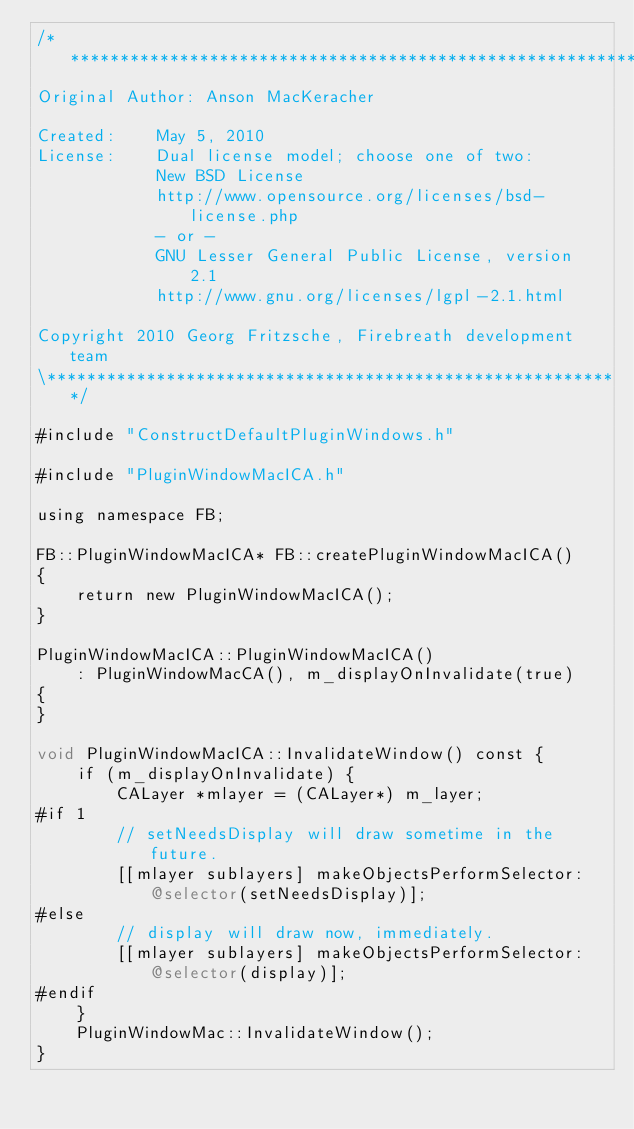Convert code to text. <code><loc_0><loc_0><loc_500><loc_500><_ObjectiveC_>/**********************************************************\
Original Author: Anson MacKeracher
 
Created:    May 5, 2010
License:    Dual license model; choose one of two:
            New BSD License
            http://www.opensource.org/licenses/bsd-license.php
            - or -
            GNU Lesser General Public License, version 2.1
            http://www.gnu.org/licenses/lgpl-2.1.html
 
Copyright 2010 Georg Fritzsche, Firebreath development team
\**********************************************************/

#include "ConstructDefaultPluginWindows.h"

#include "PluginWindowMacICA.h"

using namespace FB;

FB::PluginWindowMacICA* FB::createPluginWindowMacICA()
{
    return new PluginWindowMacICA();
}

PluginWindowMacICA::PluginWindowMacICA()
    : PluginWindowMacCA(), m_displayOnInvalidate(true)
{
}

void PluginWindowMacICA::InvalidateWindow() const {
    if (m_displayOnInvalidate) {
        CALayer *mlayer = (CALayer*) m_layer;
#if 1
        // setNeedsDisplay will draw sometime in the future.
        [[mlayer sublayers] makeObjectsPerformSelector:@selector(setNeedsDisplay)];
#else
        // display will draw now, immediately.
        [[mlayer sublayers] makeObjectsPerformSelector:@selector(display)];
#endif
    }
    PluginWindowMac::InvalidateWindow();
}
</code> 